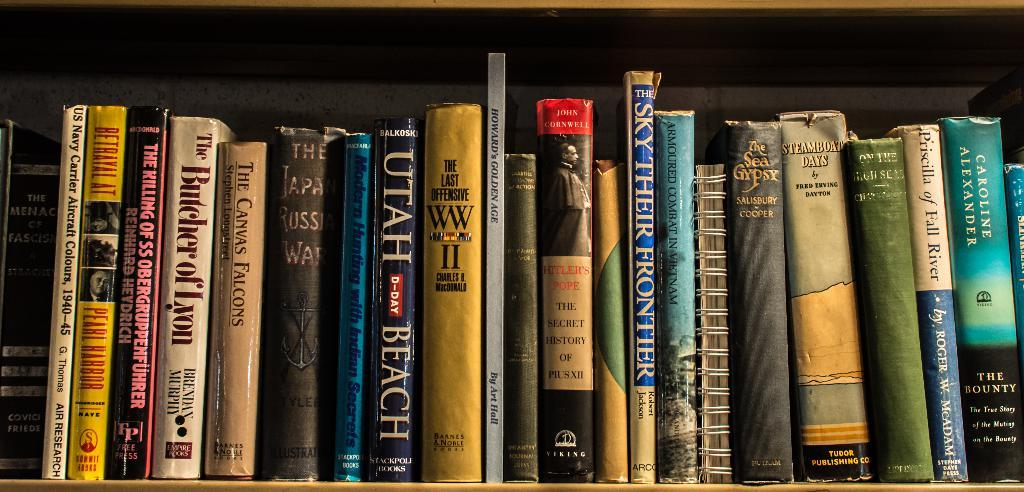<image>
Describe the image concisely. A group of books sits on a shelf with one of the books titled Utah Beach. 